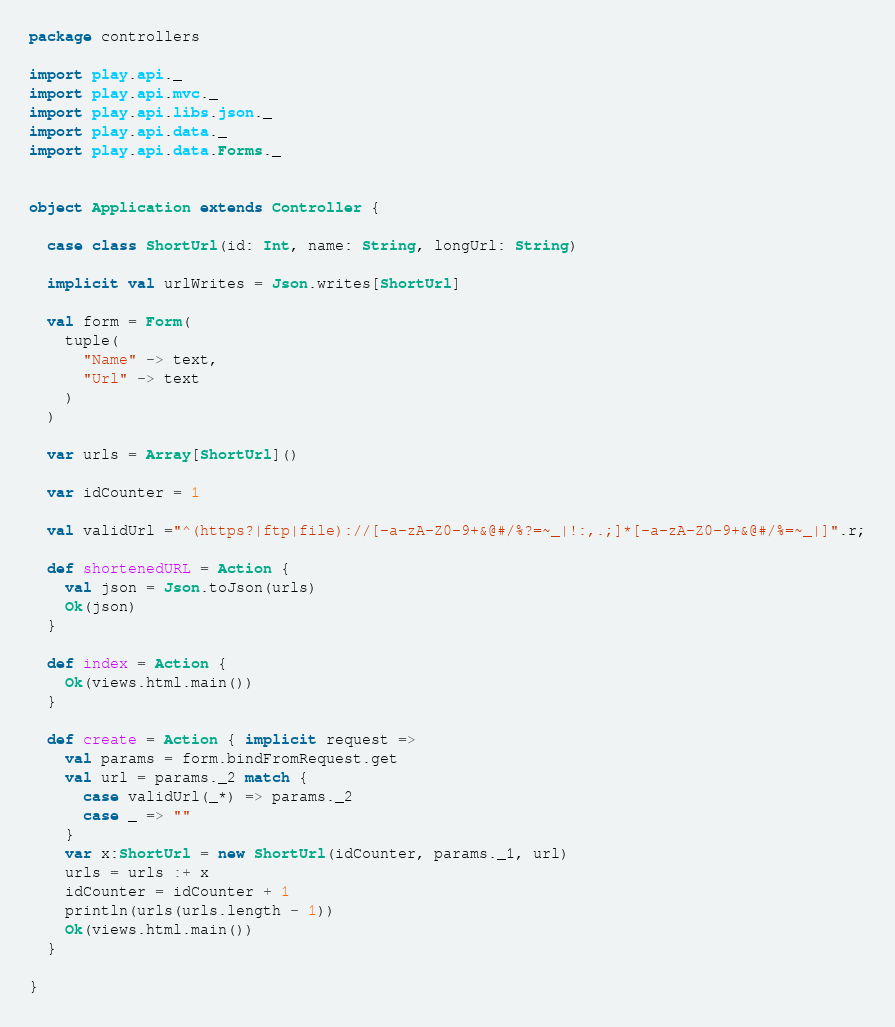<code> <loc_0><loc_0><loc_500><loc_500><_Scala_>package controllers

import play.api._
import play.api.mvc._
import play.api.libs.json._
import play.api.data._
import play.api.data.Forms._


object Application extends Controller {

  case class ShortUrl(id: Int, name: String, longUrl: String)

  implicit val urlWrites = Json.writes[ShortUrl]

  val form = Form(
    tuple(
      "Name" -> text,
      "Url" -> text
    )
  )

  var urls = Array[ShortUrl]()

  var idCounter = 1

  val validUrl ="^(https?|ftp|file)://[-a-zA-Z0-9+&@#/%?=~_|!:,.;]*[-a-zA-Z0-9+&@#/%=~_|]".r;

  def shortenedURL = Action {
    val json = Json.toJson(urls)
    Ok(json)
  }

  def index = Action {
    Ok(views.html.main())
  }

  def create = Action { implicit request =>
    val params = form.bindFromRequest.get
    val url = params._2 match {
      case validUrl(_*) => params._2
      case _ => ""
    }
    var x:ShortUrl = new ShortUrl(idCounter, params._1, url)
    urls = urls :+ x
    idCounter = idCounter + 1
    println(urls(urls.length - 1))
    Ok(views.html.main())
  }

}
</code> 